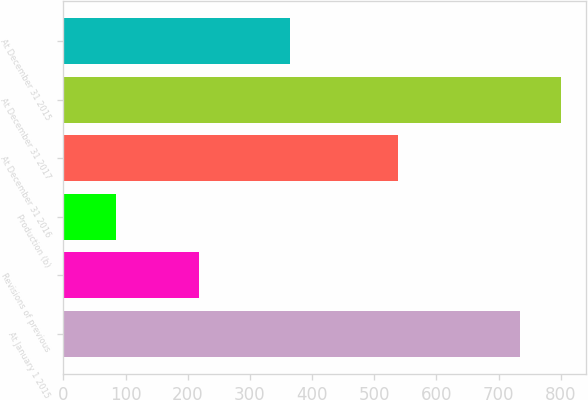Convert chart to OTSL. <chart><loc_0><loc_0><loc_500><loc_500><bar_chart><fcel>At January 1 2015<fcel>Revisions of previous<fcel>Production (b)<fcel>At December 31 2016<fcel>At December 31 2017<fcel>At December 31 2015<nl><fcel>734<fcel>218<fcel>85<fcel>539<fcel>800.6<fcel>365<nl></chart> 